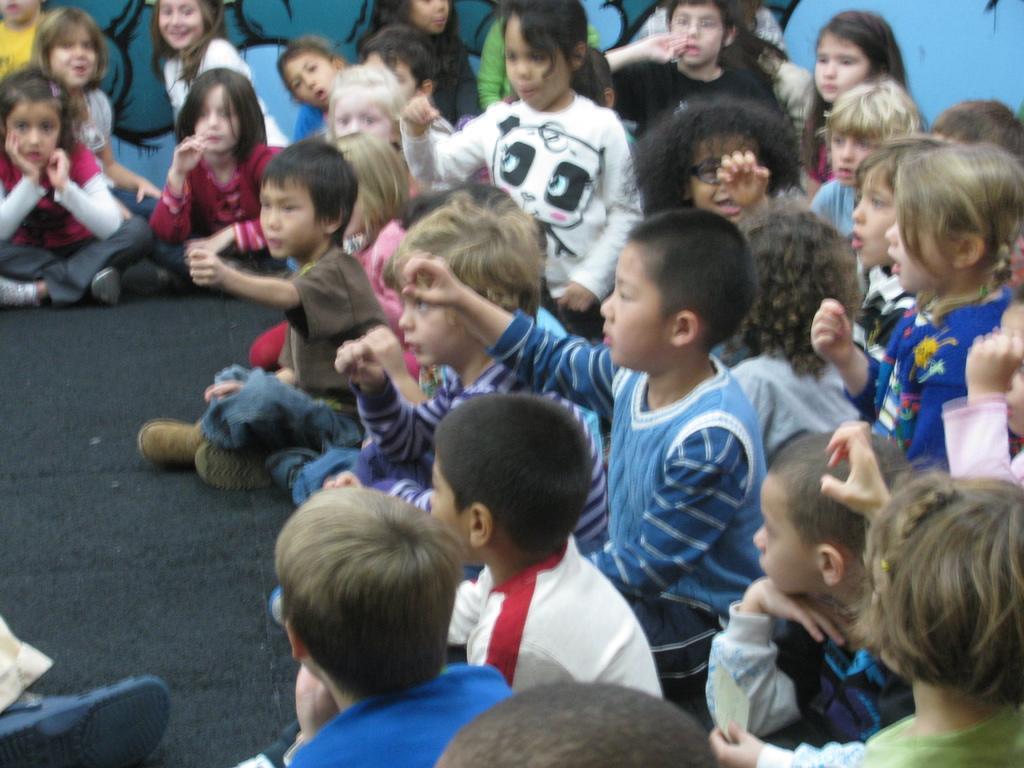In one or two sentences, can you explain what this image depicts? In this image there are persons sitting on the ground. In the background there is painting on the wall. 